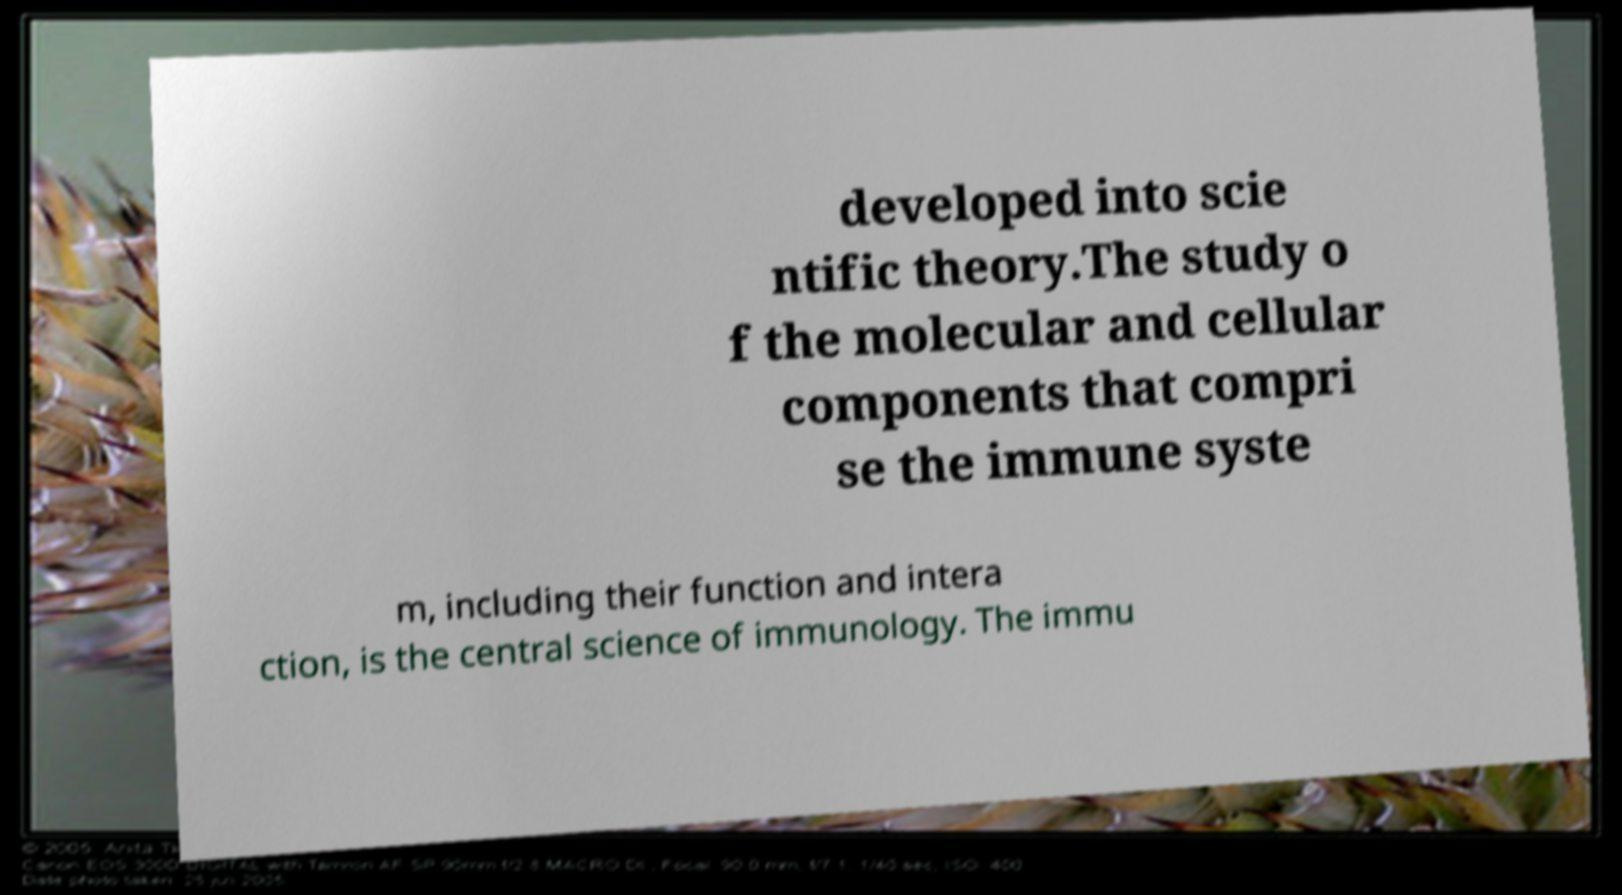Please identify and transcribe the text found in this image. developed into scie ntific theory.The study o f the molecular and cellular components that compri se the immune syste m, including their function and intera ction, is the central science of immunology. The immu 